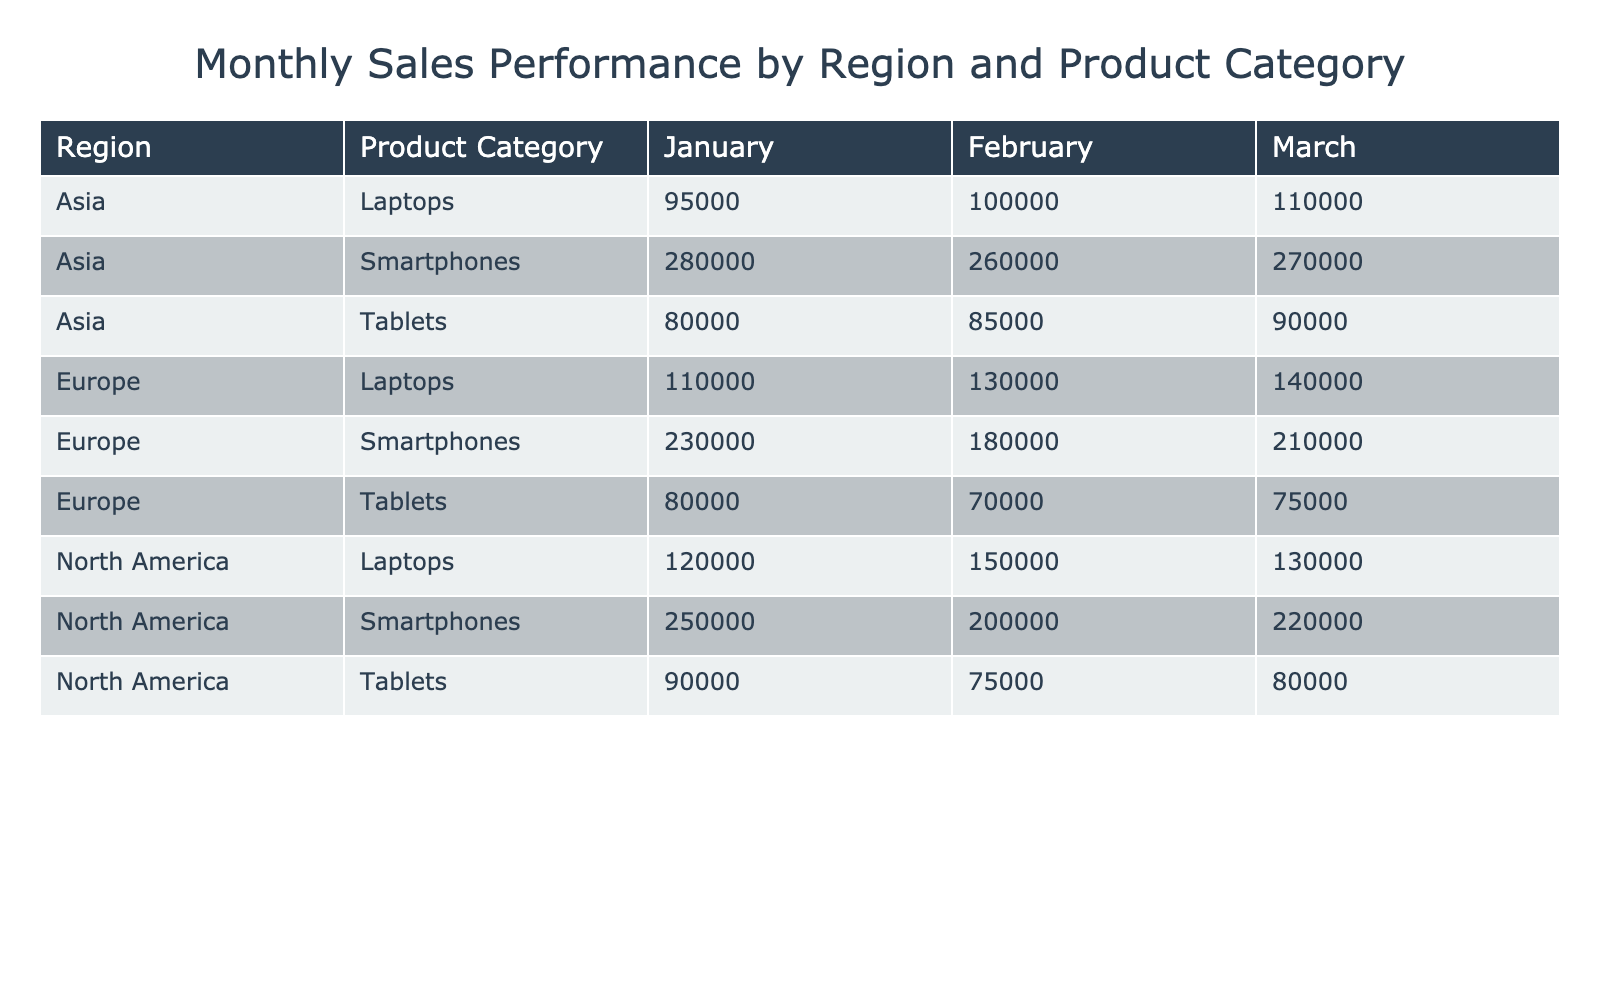What was the total sales for Laptops in North America in January? The table shows the sales for Laptops in North America in January is 150000. Since this is a single entry, the total sales for Laptops in this region and month is 150000.
Answer: 150000 Which product category had the highest sales in Europe for February? In February, the sales for product categories in Europe are: Laptops (110000), Smartphones (230000), and Tablets (80000). The highest sales among these categories is 230000 for Smartphones.
Answer: Smartphones What is the difference in sales for Tablets between January and March in Asia? For Tablets in Asia, the sales are 85000 in January and 90000 in March. The difference is calculated as 90000 - 85000 = 5000.
Answer: 5000 Did North America sell more Smartphones or Tablets in March? In March, North America sold 220000 Smartphones and 80000 Tablets. Since 220000 is greater than 80000, North America sold more Smartphones than Tablets in that month.
Answer: Yes What was the average sales of Laptops across all regions for January? The sales of Laptops in January are: North America (150000), Europe (130000), and Asia (100000). To find the average, sum the values: 150000 + 130000 + 100000 = 380000, then divide by 3 (the number of regions): 380000/3 = 126667.
Answer: 126667 Which month had the lowest total sales for Tablets across all regions? The sales for Tablets across all regions in each month are: January (75000 + 70000 + 85000 = 230000), February (90000 + 80000 + 80000 = 250000), and March (80000 + 75000 + 90000 = 245000). The lowest total sales are in January with 230000.
Answer: January What are the total sales for both Laptops and Smartphones in Europe for March? In March for Europe, the sales for Laptops is 140000 and for Smartphones is 210000. The total sales are 140000 + 210000 = 350000.
Answer: 350000 Was the total sales for Laptops in Asia greater than the total sales for Laptops in North America for March? The sales for March Laptops are: Asia (110000) and North America (130000). Since 110000 is less than 130000, the total sales in Asia was not greater than that in North America for March.
Answer: No 